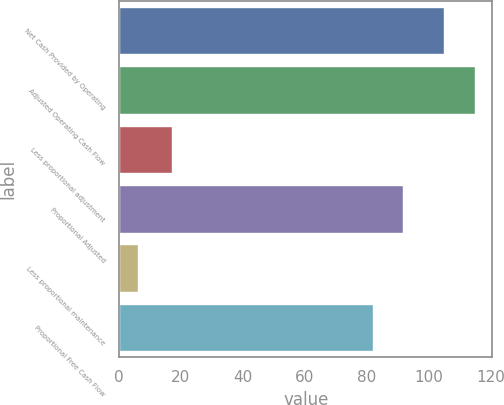Convert chart to OTSL. <chart><loc_0><loc_0><loc_500><loc_500><bar_chart><fcel>Net Cash Provided by Operating<fcel>Adjusted Operating Cash Flow<fcel>Less proportional adjustment<fcel>Proportional Adjusted<fcel>Less proportional maintenance<fcel>Proportional Free Cash Flow<nl><fcel>105<fcel>114.9<fcel>17<fcel>91.9<fcel>6<fcel>82<nl></chart> 